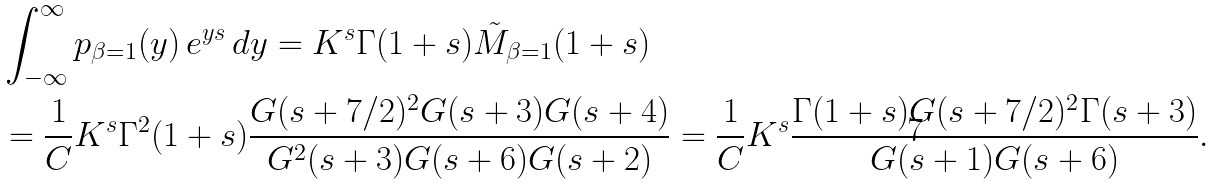Convert formula to latex. <formula><loc_0><loc_0><loc_500><loc_500>& \int _ { - \infty } ^ { \infty } p _ { \beta = 1 } ( y ) \, e ^ { y s } \, d y = K ^ { s } \Gamma ( 1 + s ) \tilde { M } _ { \beta = 1 } ( 1 + s ) \\ & = \frac { 1 } { C } K ^ { s } \Gamma ^ { 2 } ( 1 + s ) \frac { G ( s + 7 / 2 ) ^ { 2 } G ( s + 3 ) G ( s + 4 ) } { G ^ { 2 } ( s + 3 ) G ( s + 6 ) G ( s + 2 ) } = \frac { 1 } { C } K ^ { s } \frac { \Gamma ( 1 + s ) G ( s + 7 / 2 ) ^ { 2 } \Gamma ( s + 3 ) } { G ( s + 1 ) G ( s + 6 ) } .</formula> 